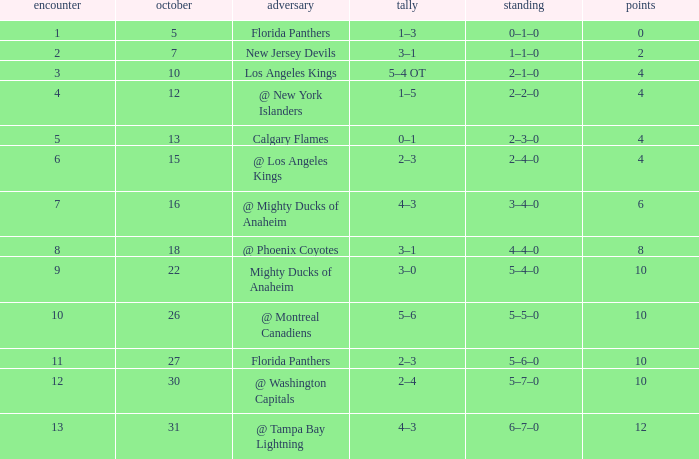Give me the full table as a dictionary. {'header': ['encounter', 'october', 'adversary', 'tally', 'standing', 'points'], 'rows': [['1', '5', 'Florida Panthers', '1–3', '0–1–0', '0'], ['2', '7', 'New Jersey Devils', '3–1', '1–1–0', '2'], ['3', '10', 'Los Angeles Kings', '5–4 OT', '2–1–0', '4'], ['4', '12', '@ New York Islanders', '1–5', '2–2–0', '4'], ['5', '13', 'Calgary Flames', '0–1', '2–3–0', '4'], ['6', '15', '@ Los Angeles Kings', '2–3', '2–4–0', '4'], ['7', '16', '@ Mighty Ducks of Anaheim', '4–3', '3–4–0', '6'], ['8', '18', '@ Phoenix Coyotes', '3–1', '4–4–0', '8'], ['9', '22', 'Mighty Ducks of Anaheim', '3–0', '5–4–0', '10'], ['10', '26', '@ Montreal Canadiens', '5–6', '5–5–0', '10'], ['11', '27', 'Florida Panthers', '2–3', '5–6–0', '10'], ['12', '30', '@ Washington Capitals', '2–4', '5–7–0', '10'], ['13', '31', '@ Tampa Bay Lightning', '4–3', '6–7–0', '12']]} What team has a score of 11 5–6–0. 